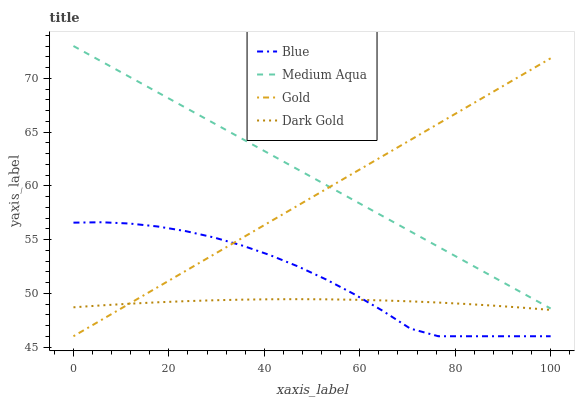Does Gold have the minimum area under the curve?
Answer yes or no. No. Does Gold have the maximum area under the curve?
Answer yes or no. No. Is Medium Aqua the smoothest?
Answer yes or no. No. Is Medium Aqua the roughest?
Answer yes or no. No. Does Medium Aqua have the lowest value?
Answer yes or no. No. Does Gold have the highest value?
Answer yes or no. No. Is Blue less than Medium Aqua?
Answer yes or no. Yes. Is Medium Aqua greater than Dark Gold?
Answer yes or no. Yes. Does Blue intersect Medium Aqua?
Answer yes or no. No. 